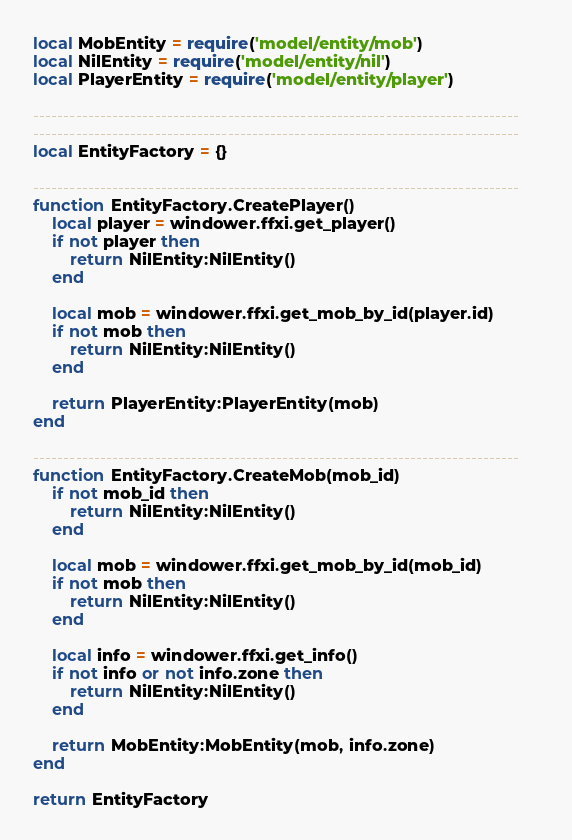Convert code to text. <code><loc_0><loc_0><loc_500><loc_500><_Lua_>local MobEntity = require('model/entity/mob')
local NilEntity = require('model/entity/nil')
local PlayerEntity = require('model/entity/player')

--------------------------------------------------------------------------------
--------------------------------------------------------------------------------
local EntityFactory = {}

--------------------------------------------------------------------------------
function EntityFactory.CreatePlayer()
    local player = windower.ffxi.get_player()
    if not player then
        return NilEntity:NilEntity()
    end

    local mob = windower.ffxi.get_mob_by_id(player.id)
    if not mob then
        return NilEntity:NilEntity()
    end

    return PlayerEntity:PlayerEntity(mob)
end

--------------------------------------------------------------------------------
function EntityFactory.CreateMob(mob_id)
    if not mob_id then
        return NilEntity:NilEntity()
    end

    local mob = windower.ffxi.get_mob_by_id(mob_id)
    if not mob then
        return NilEntity:NilEntity()
    end

    local info = windower.ffxi.get_info()
    if not info or not info.zone then
        return NilEntity:NilEntity()
    end

    return MobEntity:MobEntity(mob, info.zone)
end

return EntityFactory
</code> 